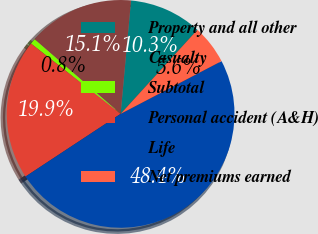<chart> <loc_0><loc_0><loc_500><loc_500><pie_chart><fcel>Property and all other<fcel>Casualty<fcel>Subtotal<fcel>Personal accident (A&H)<fcel>Life<fcel>Net premiums earned<nl><fcel>10.32%<fcel>15.09%<fcel>0.78%<fcel>19.86%<fcel>48.39%<fcel>5.55%<nl></chart> 